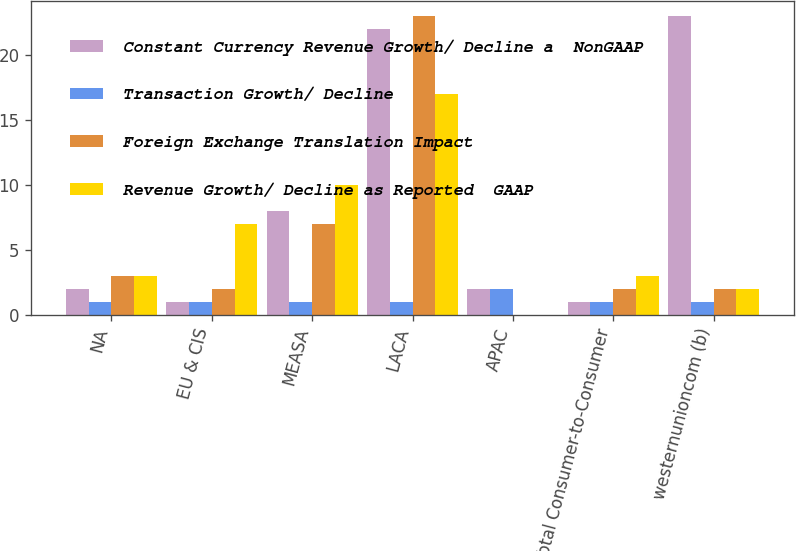<chart> <loc_0><loc_0><loc_500><loc_500><stacked_bar_chart><ecel><fcel>NA<fcel>EU & CIS<fcel>MEASA<fcel>LACA<fcel>APAC<fcel>Total Consumer-to-Consumer<fcel>westernunioncom (b)<nl><fcel>Constant Currency Revenue Growth/ Decline a  NonGAAP<fcel>2<fcel>1<fcel>8<fcel>22<fcel>2<fcel>1<fcel>23<nl><fcel>Transaction Growth/ Decline<fcel>1<fcel>1<fcel>1<fcel>1<fcel>2<fcel>1<fcel>1<nl><fcel>Foreign Exchange Translation Impact<fcel>3<fcel>2<fcel>7<fcel>23<fcel>0<fcel>2<fcel>2<nl><fcel>Revenue Growth/ Decline as Reported  GAAP<fcel>3<fcel>7<fcel>10<fcel>17<fcel>0<fcel>3<fcel>2<nl></chart> 